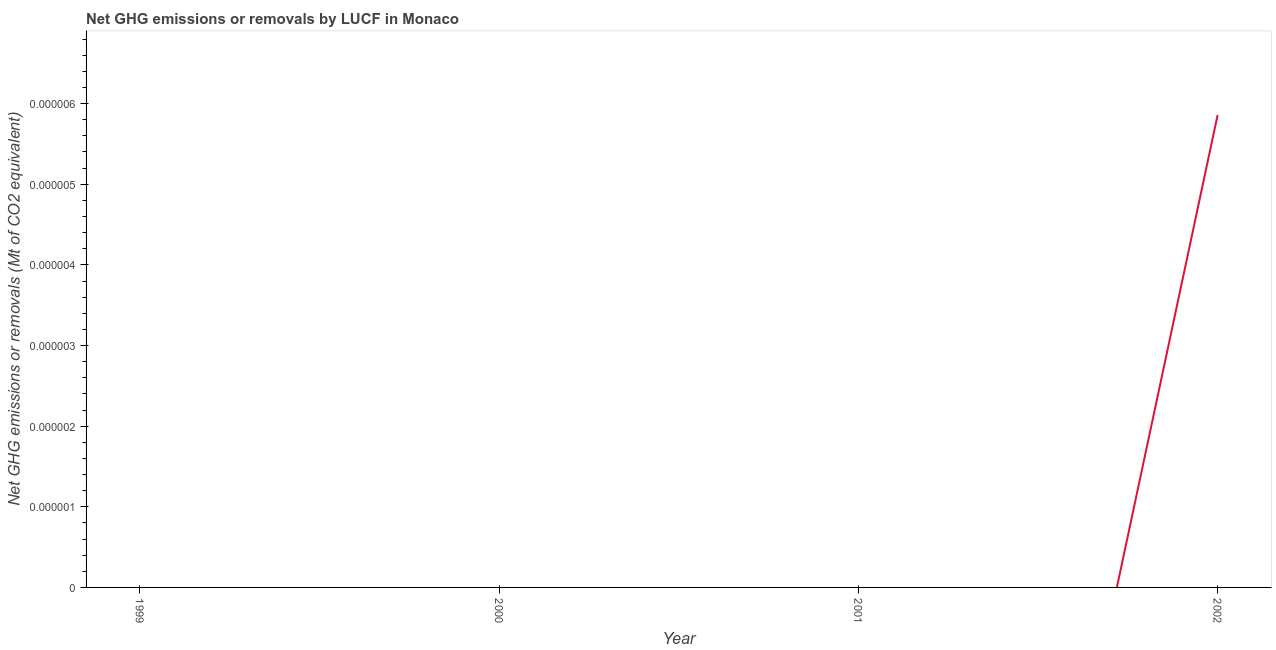What is the ghg net emissions or removals in 2002?
Provide a succinct answer. 5.858356041736519e-6. Across all years, what is the maximum ghg net emissions or removals?
Your response must be concise. 5.858356041736519e-6. Across all years, what is the minimum ghg net emissions or removals?
Provide a short and direct response. 0. What is the sum of the ghg net emissions or removals?
Keep it short and to the point. 5.858356041736519e-6. What is the average ghg net emissions or removals per year?
Give a very brief answer. 1.4645890104341297e-6. What is the median ghg net emissions or removals?
Provide a short and direct response. 0. In how many years, is the ghg net emissions or removals greater than 1.8e-06 Mt?
Your answer should be compact. 1. What is the difference between the highest and the lowest ghg net emissions or removals?
Provide a short and direct response. 5.858356041736519e-6. In how many years, is the ghg net emissions or removals greater than the average ghg net emissions or removals taken over all years?
Provide a short and direct response. 1. What is the difference between two consecutive major ticks on the Y-axis?
Offer a terse response. 1e-6. What is the title of the graph?
Offer a very short reply. Net GHG emissions or removals by LUCF in Monaco. What is the label or title of the Y-axis?
Ensure brevity in your answer.  Net GHG emissions or removals (Mt of CO2 equivalent). What is the Net GHG emissions or removals (Mt of CO2 equivalent) in 1999?
Provide a short and direct response. 0. What is the Net GHG emissions or removals (Mt of CO2 equivalent) of 2000?
Give a very brief answer. 0. What is the Net GHG emissions or removals (Mt of CO2 equivalent) of 2001?
Offer a terse response. 0. What is the Net GHG emissions or removals (Mt of CO2 equivalent) in 2002?
Your response must be concise. 5.858356041736519e-6. 